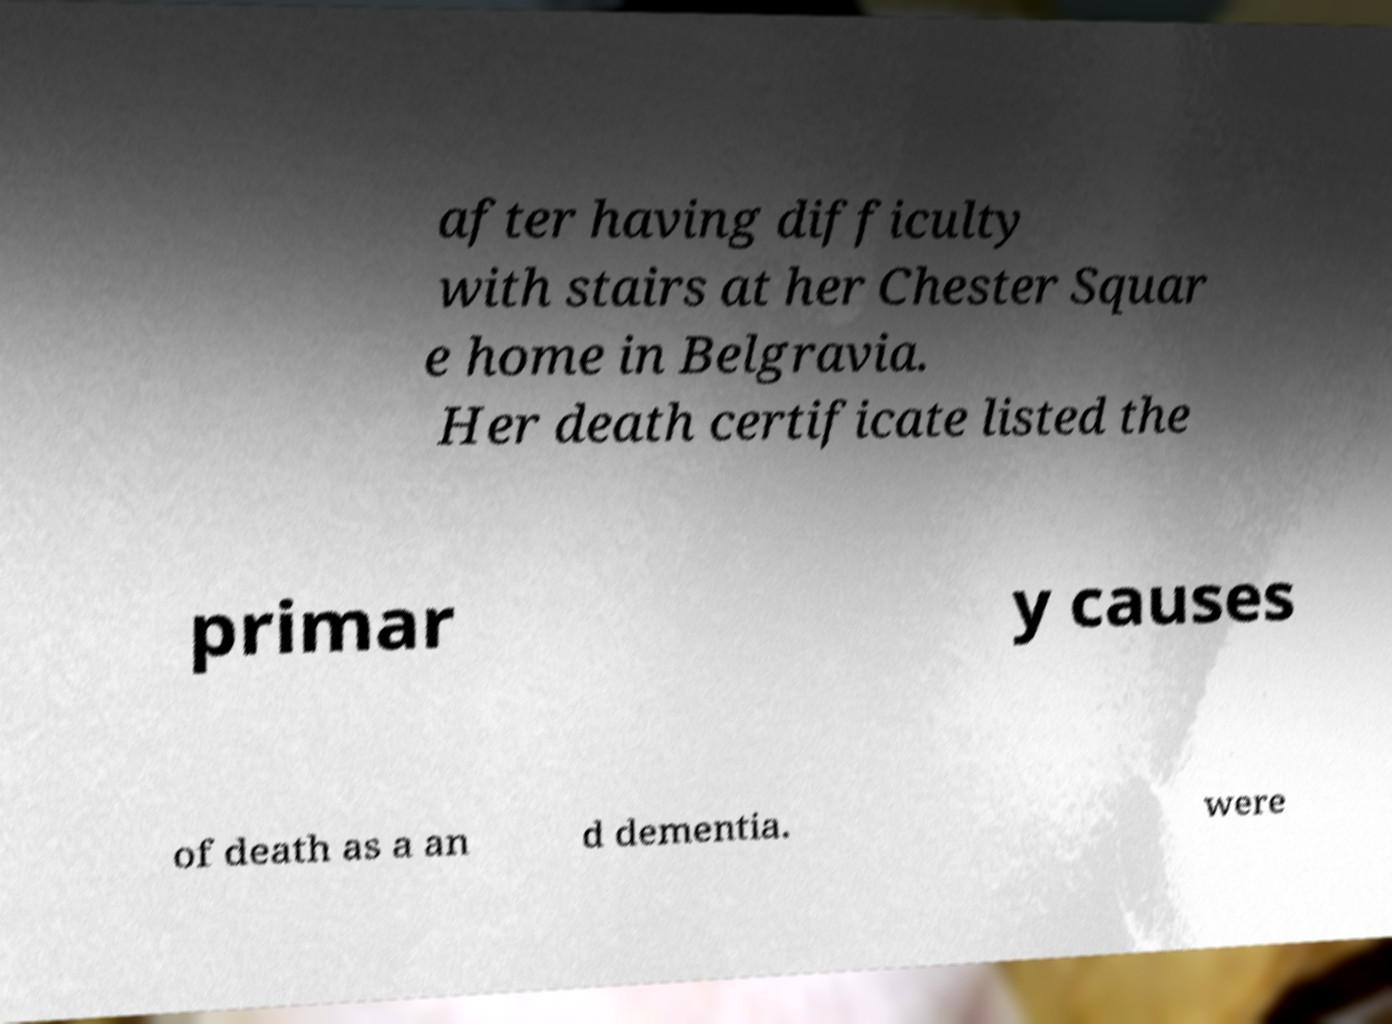For documentation purposes, I need the text within this image transcribed. Could you provide that? after having difficulty with stairs at her Chester Squar e home in Belgravia. Her death certificate listed the primar y causes of death as a an d dementia. were 